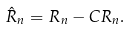<formula> <loc_0><loc_0><loc_500><loc_500>\hat { R } _ { n } = R _ { n } - C R _ { n } .</formula> 